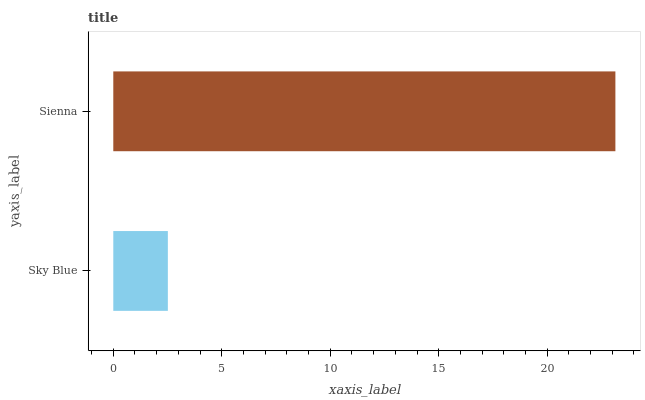Is Sky Blue the minimum?
Answer yes or no. Yes. Is Sienna the maximum?
Answer yes or no. Yes. Is Sienna the minimum?
Answer yes or no. No. Is Sienna greater than Sky Blue?
Answer yes or no. Yes. Is Sky Blue less than Sienna?
Answer yes or no. Yes. Is Sky Blue greater than Sienna?
Answer yes or no. No. Is Sienna less than Sky Blue?
Answer yes or no. No. Is Sienna the high median?
Answer yes or no. Yes. Is Sky Blue the low median?
Answer yes or no. Yes. Is Sky Blue the high median?
Answer yes or no. No. Is Sienna the low median?
Answer yes or no. No. 